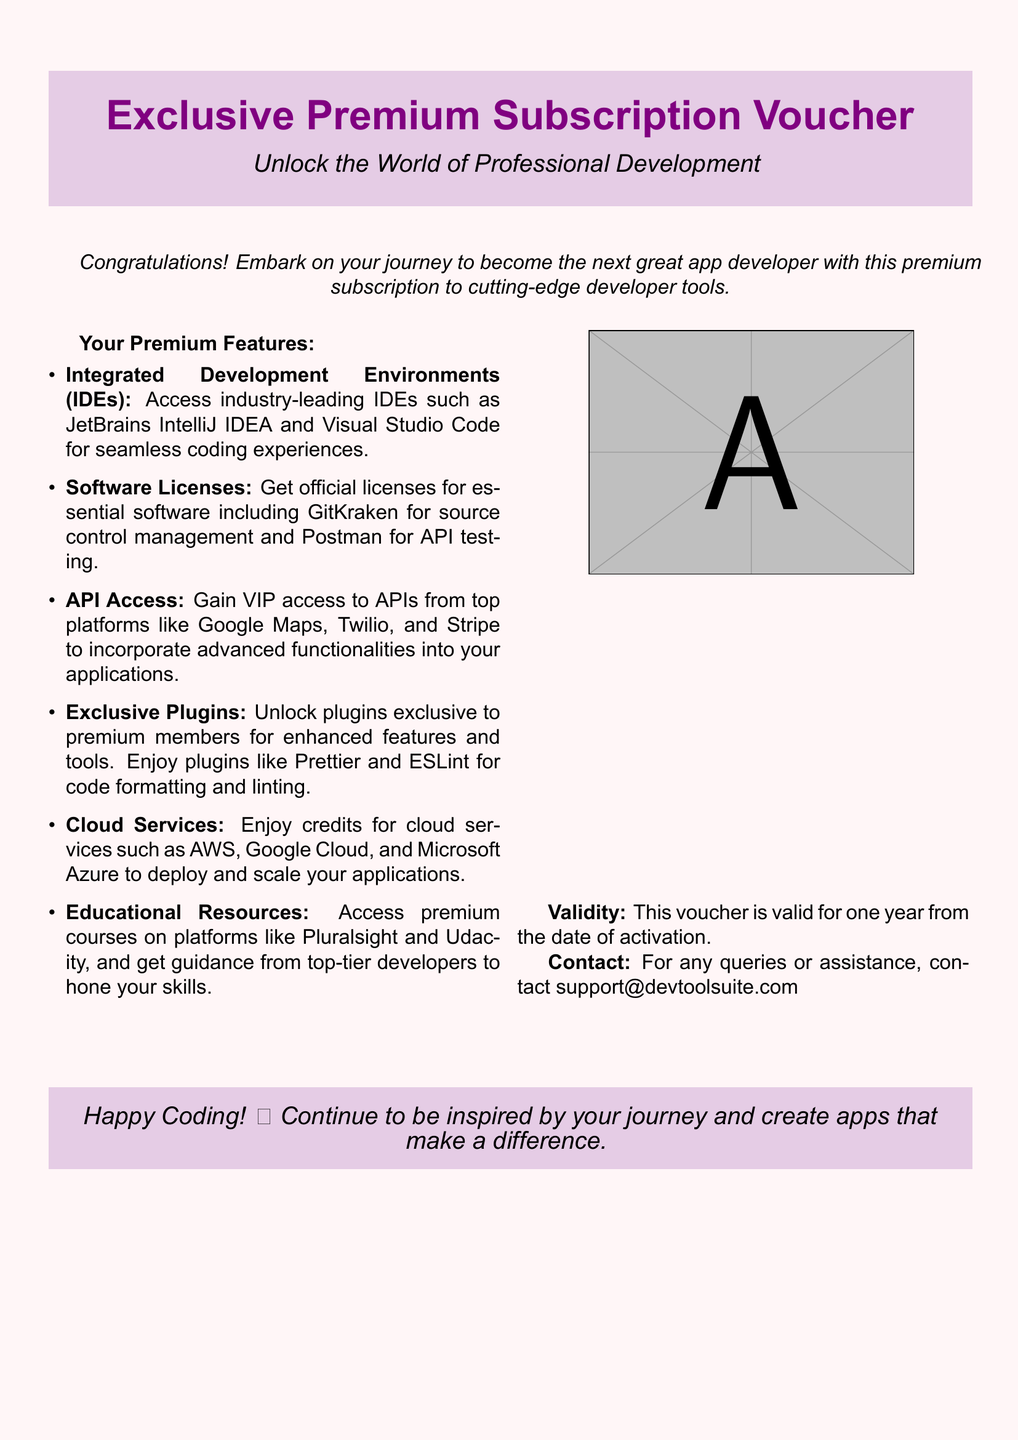What is the title of the voucher? The title of the voucher is prominently displayed at the top of the document, which is "Exclusive Premium Subscription Voucher."
Answer: Exclusive Premium Subscription Voucher What is the validity period of the voucher? The document states that the voucher is valid for one year from the date of activation.
Answer: One year What software is included for source control management? The document lists "GitKraken" as the essential software for source control management included with the premium subscription.
Answer: GitKraken Which platforms provide API access through this voucher? The document mentions various platforms for API access, including "Google Maps, Twilio, and Stripe."
Answer: Google Maps, Twilio, and Stripe What feature is related to cloud services? The voucher includes "credits for cloud services" such as AWS, Google Cloud, and Microsoft Azure.
Answer: Credits for cloud services Where can users get premium courses? The document specifies that premium courses can be accessed on platforms like "Pluralsight and Udacity."
Answer: Pluralsight and Udacity What type of resources does the voucher provide? The document mentions "educational resources" as part of the features provided by the voucher.
Answer: Educational resources What should users do for any assistance? The document advises users to contact a specific email for queries or assistance, which is "support@devtoolsuite.com."
Answer: support@devtoolsuite.com 